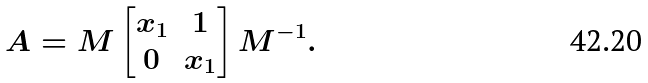Convert formula to latex. <formula><loc_0><loc_0><loc_500><loc_500>A & = M \begin{bmatrix} x _ { 1 } & 1 \\ 0 & x _ { 1 } \end{bmatrix} M ^ { - 1 } .</formula> 